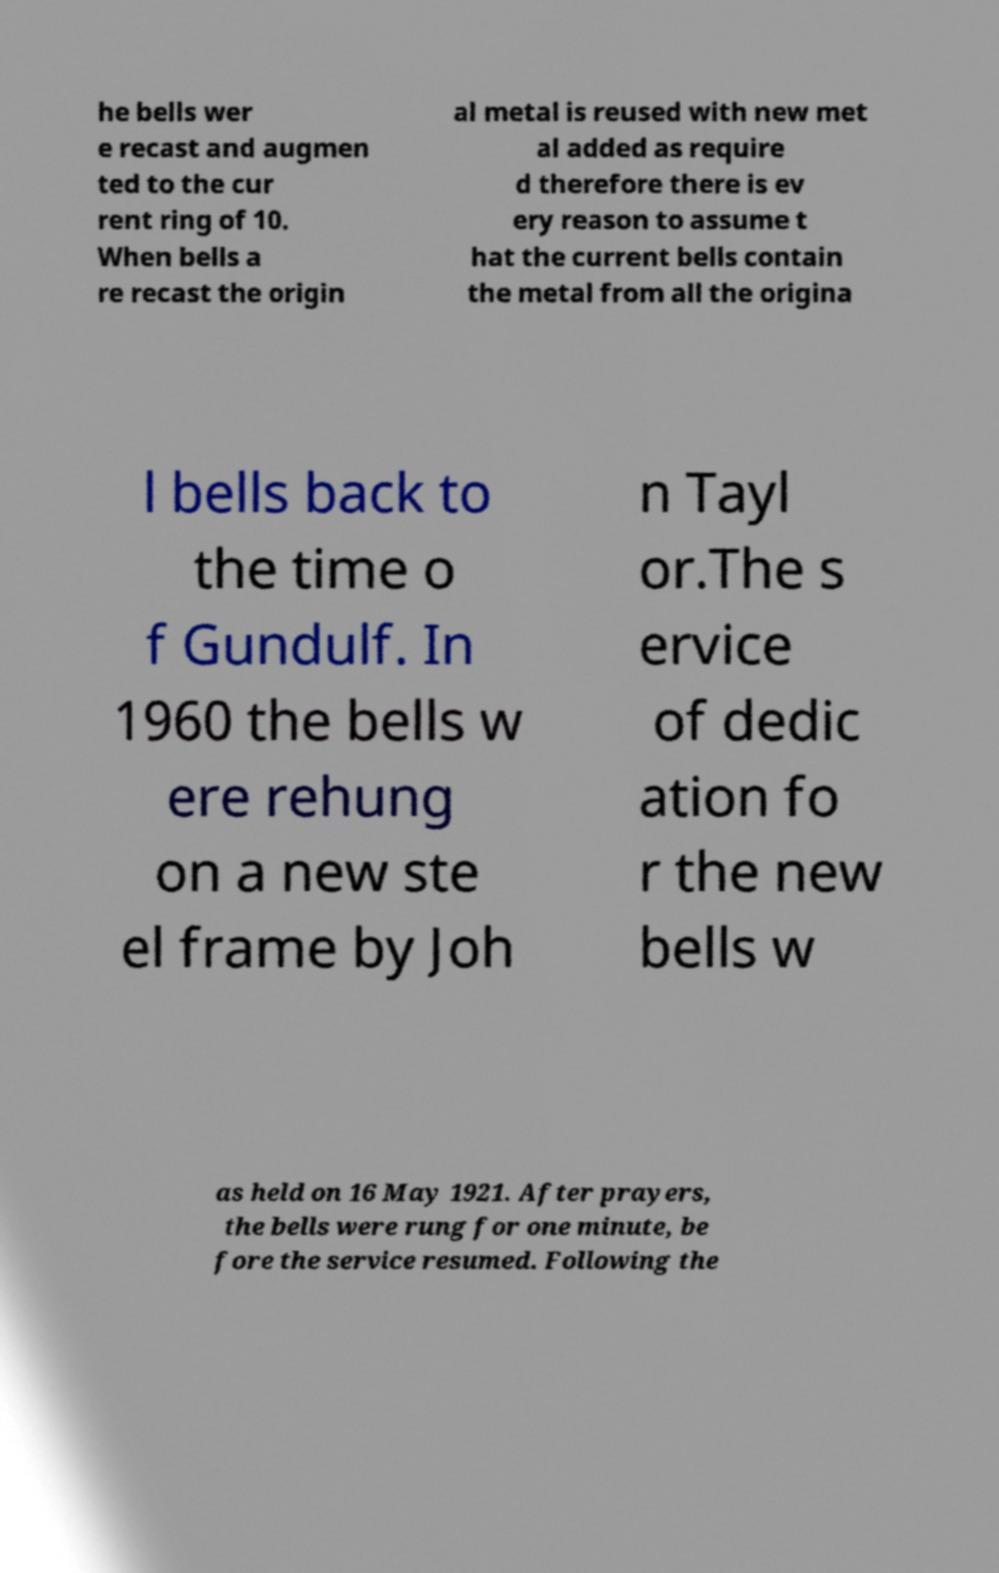There's text embedded in this image that I need extracted. Can you transcribe it verbatim? he bells wer e recast and augmen ted to the cur rent ring of 10. When bells a re recast the origin al metal is reused with new met al added as require d therefore there is ev ery reason to assume t hat the current bells contain the metal from all the origina l bells back to the time o f Gundulf. In 1960 the bells w ere rehung on a new ste el frame by Joh n Tayl or.The s ervice of dedic ation fo r the new bells w as held on 16 May 1921. After prayers, the bells were rung for one minute, be fore the service resumed. Following the 